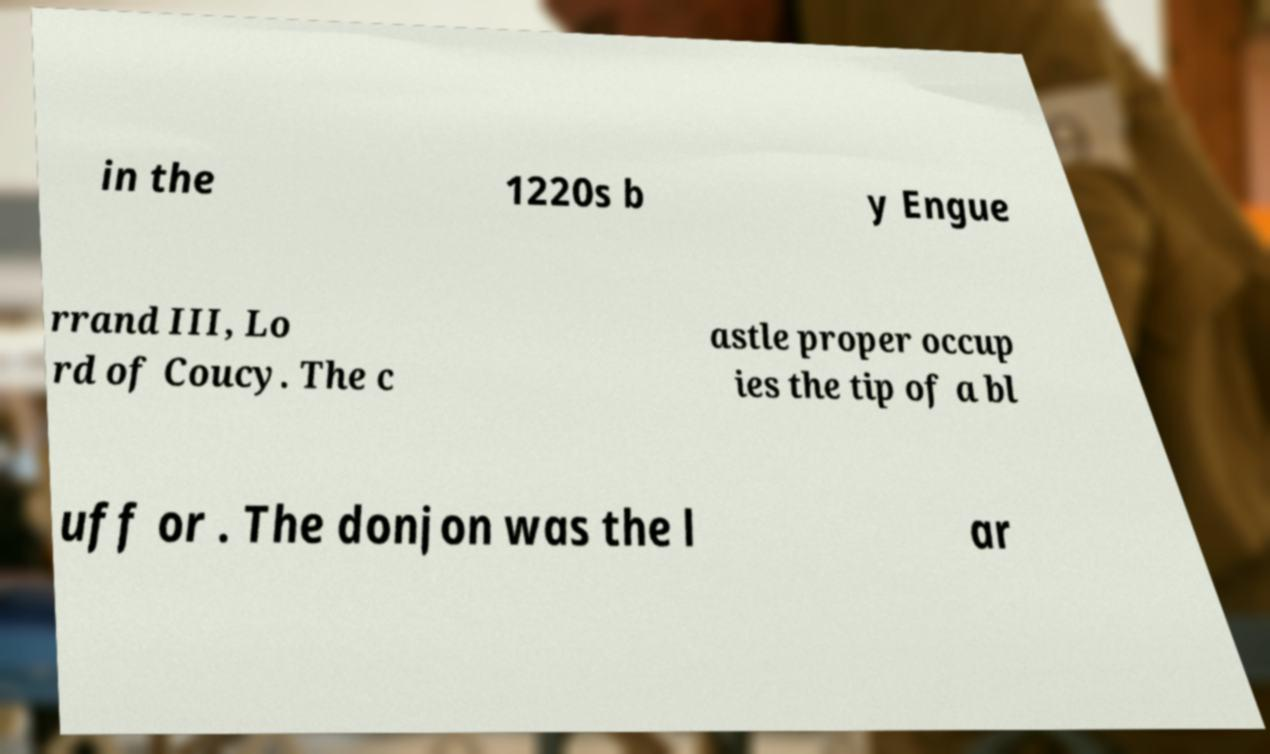I need the written content from this picture converted into text. Can you do that? in the 1220s b y Engue rrand III, Lo rd of Coucy. The c astle proper occup ies the tip of a bl uff or . The donjon was the l ar 